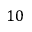<formula> <loc_0><loc_0><loc_500><loc_500>1 0</formula> 